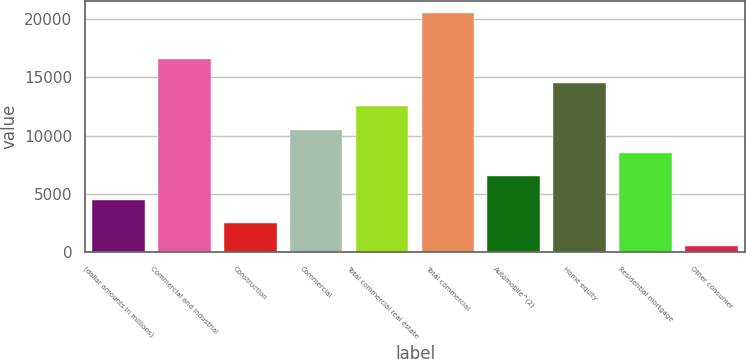Convert chart. <chart><loc_0><loc_0><loc_500><loc_500><bar_chart><fcel>(dollar amounts in millions)<fcel>Commercial and industrial<fcel>Construction<fcel>Commercial<fcel>Total commercial real estate<fcel>Total commercial<fcel>Automobile^(2)<fcel>Home equity<fcel>Residential mortgage<fcel>Other consumer<nl><fcel>4503.4<fcel>16519.6<fcel>2500.7<fcel>10511.5<fcel>12514.2<fcel>20525<fcel>6506.1<fcel>14516.9<fcel>8508.8<fcel>498<nl></chart> 